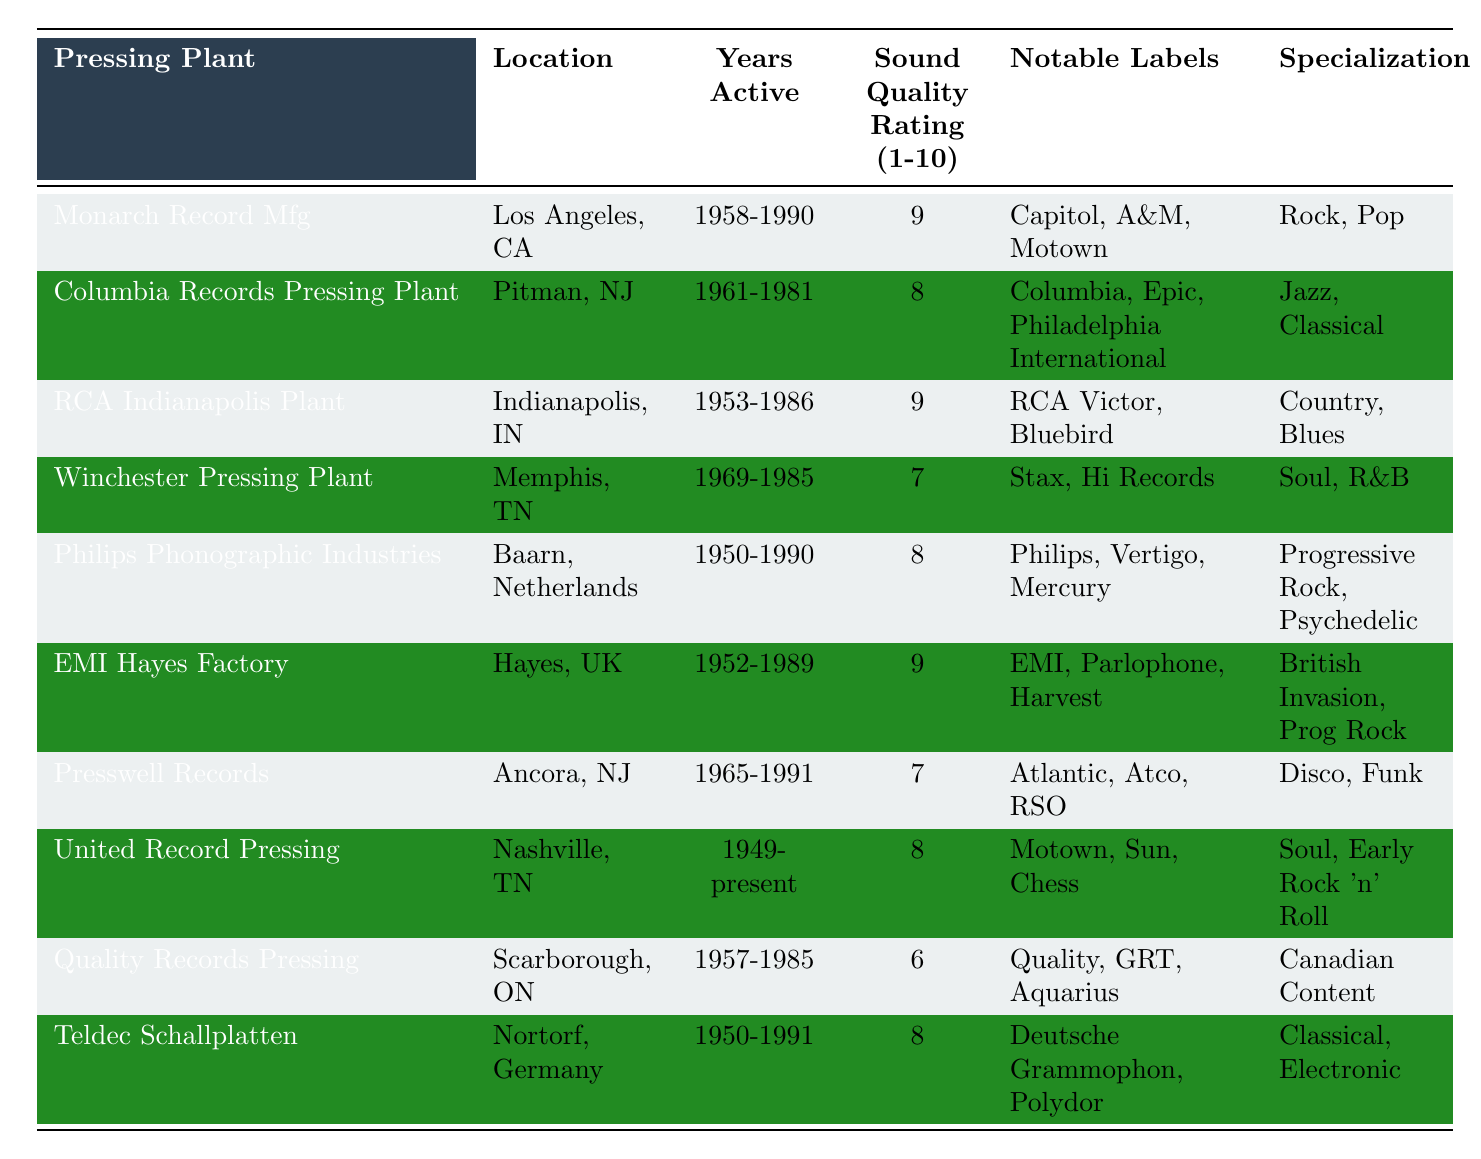What is the highest sound quality rating among the pressing plants? By inspecting the "Sound Quality Rating" column, the highest rating is 9. There are three pressing plants that have this rating: Monarch Record Mfg, RCA Indianapolis Plant, and EMI Hayes Factory.
Answer: 9 Which pressing plant specializes in Country and Blues? The table indicates that the RCA Indianapolis Plant specializes in Country and Blues, as shown in the "Specialization" column.
Answer: RCA Indianapolis Plant How many pressing plants have a sound quality rating of 8 or higher? Checking the "Sound Quality Rating" column, the pressing plants with ratings of 9 (three plants) and ratings of 8 (four plants) leads to a total of 7 plants with ratings of 8 or higher.
Answer: 7 Is there any pressing plant located in Canada? The table lists Quality Records Pressing located in Scarborough, Ontario, which is in Canada. Hence, the answer is yes.
Answer: Yes What is the specialization of the pressing plant with the lowest sound quality rating? The Quality Records Pressing has a sound quality rating of 6, and its specialization is Canadian Content. This corresponds to the lowest rating in the table.
Answer: Canadian Content How does the average sound quality rating of pressing plants in the U.S. compare to those outside the U.S.? The U.S. plants have ratings of 9, 8, 9, 7, 7, and 6 totaling 46 from 6 plants, leading to an average of 46/6 = 7.67. The plants outside the U.S. have ratings of 8 and 8 totaling 16 from 2 plants, giving an average of 16/2 = 8. Thus, the U.S. average is lower than the non-U.S. average.
Answer: U.S. average is lower List the notable labels for the pressing plant with the longest active years. United Record Pressing, which is active from 1949 to the present, has notable labels including Motown, Sun, and Chess, as shown in the "Notable Labels" column.
Answer: Motown, Sun, Chess What years did Philips Phonographic Industries operate? The "Years Active" column states that Philips Phonographic Industries operated from 1950 to 1990.
Answer: 1950-1990 Which pressing plant has a specialization in Progressive Rock and Psychedelic music? Philips Phonographic Industries is noted to specialize in Progressive Rock and Psychedelic music, as indicated in the "Specialization" column.
Answer: Philips Phonographic Industries How many pressing plants have a sound quality rating of 7? From the table, two plants, Winchester Pressing Plant and Presswell Records, each have a rating of 7, leading to a total of 2 plants with this rating.
Answer: 2 Do any pressing plants have a specialization in Disco? Yes, the Presswell Records specializes in Disco, which can be verified from the "Specialization" column in the table.
Answer: Yes 